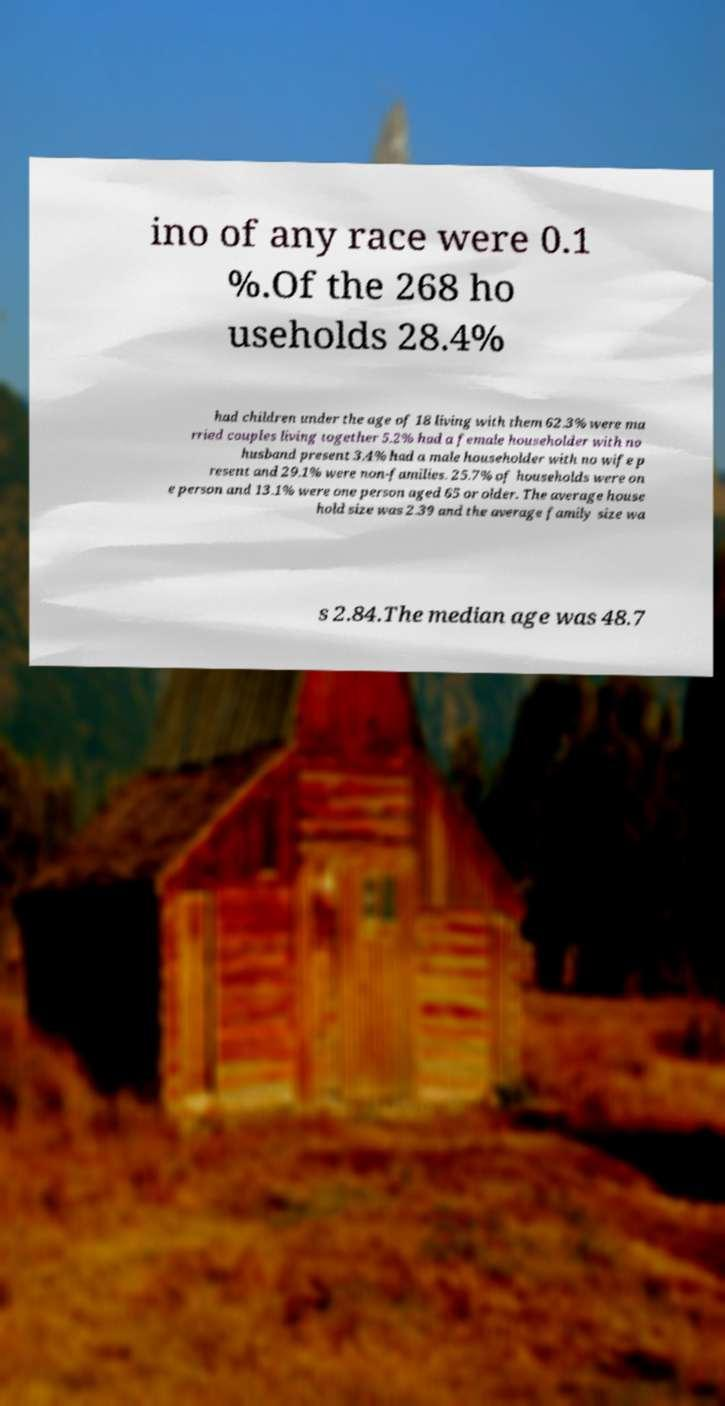There's text embedded in this image that I need extracted. Can you transcribe it verbatim? ino of any race were 0.1 %.Of the 268 ho useholds 28.4% had children under the age of 18 living with them 62.3% were ma rried couples living together 5.2% had a female householder with no husband present 3.4% had a male householder with no wife p resent and 29.1% were non-families. 25.7% of households were on e person and 13.1% were one person aged 65 or older. The average house hold size was 2.39 and the average family size wa s 2.84.The median age was 48.7 